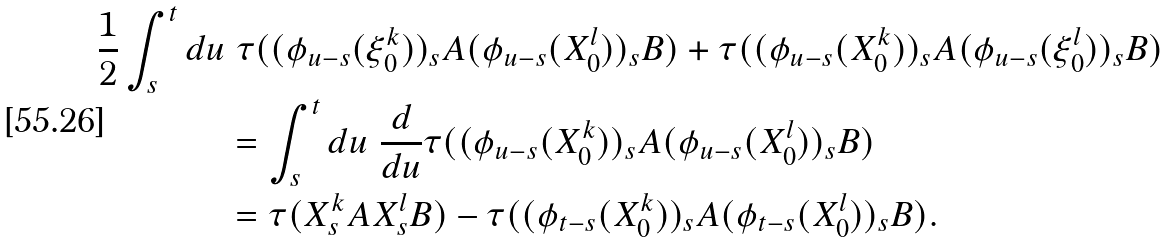<formula> <loc_0><loc_0><loc_500><loc_500>\frac { 1 } { 2 } \int _ { s } ^ { t } d u & \ \tau ( ( \phi _ { u - s } ( \xi _ { 0 } ^ { k } ) ) _ { s } A ( \phi _ { u - s } ( X _ { 0 } ^ { l } ) ) _ { s } B ) + \tau ( ( \phi _ { u - s } ( X _ { 0 } ^ { k } ) ) _ { s } A ( \phi _ { u - s } ( \xi _ { 0 } ^ { l } ) ) _ { s } B ) \\ & = \int _ { s } ^ { t } d u \ \frac { d } { d u } \tau ( ( \phi _ { u - s } ( X _ { 0 } ^ { k } ) ) _ { s } A ( \phi _ { u - s } ( X _ { 0 } ^ { l } ) ) _ { s } B ) \\ & = \tau ( X _ { s } ^ { k } A X _ { s } ^ { l } B ) - \tau ( ( \phi _ { t - s } ( X _ { 0 } ^ { k } ) ) _ { s } A ( \phi _ { t - s } ( X _ { 0 } ^ { l } ) ) _ { s } B ) .</formula> 